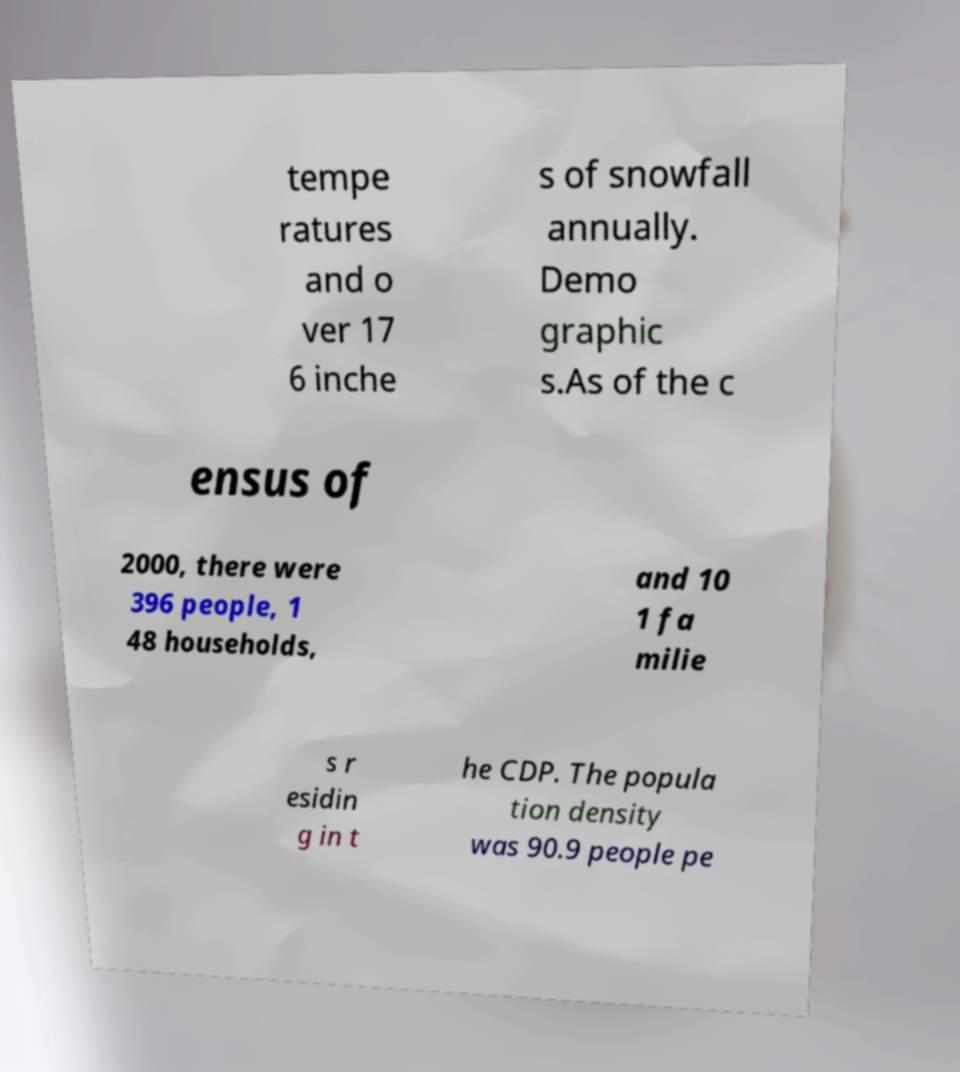Please read and relay the text visible in this image. What does it say? tempe ratures and o ver 17 6 inche s of snowfall annually. Demo graphic s.As of the c ensus of 2000, there were 396 people, 1 48 households, and 10 1 fa milie s r esidin g in t he CDP. The popula tion density was 90.9 people pe 